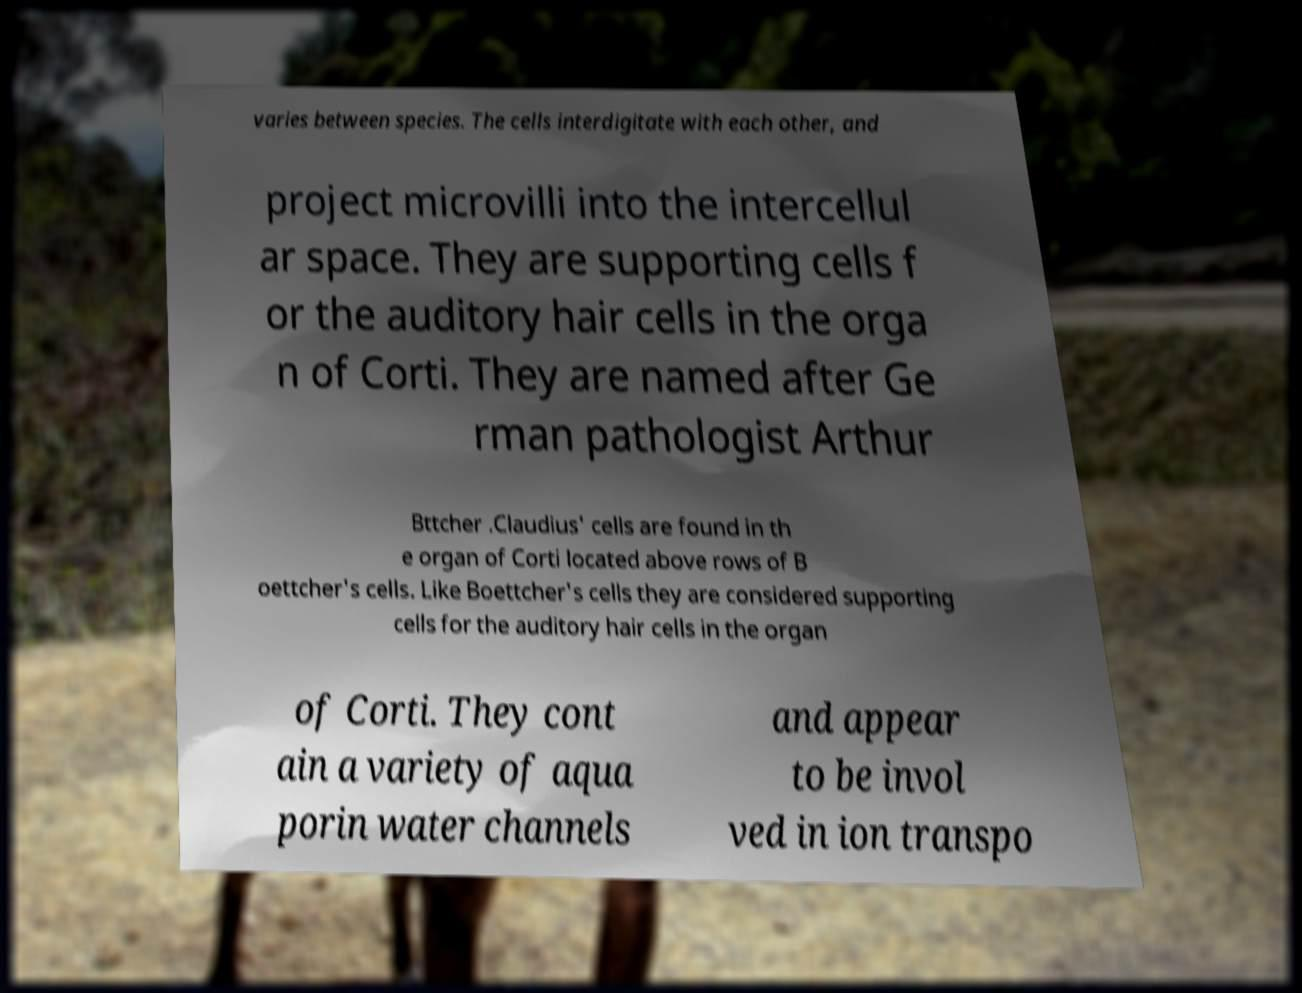There's text embedded in this image that I need extracted. Can you transcribe it verbatim? varies between species. The cells interdigitate with each other, and project microvilli into the intercellul ar space. They are supporting cells f or the auditory hair cells in the orga n of Corti. They are named after Ge rman pathologist Arthur Bttcher .Claudius' cells are found in th e organ of Corti located above rows of B oettcher's cells. Like Boettcher's cells they are considered supporting cells for the auditory hair cells in the organ of Corti. They cont ain a variety of aqua porin water channels and appear to be invol ved in ion transpo 